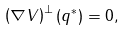Convert formula to latex. <formula><loc_0><loc_0><loc_500><loc_500>\left ( \nabla V \right ) ^ { \perp } ( { q } ^ { * } ) = 0 ,</formula> 